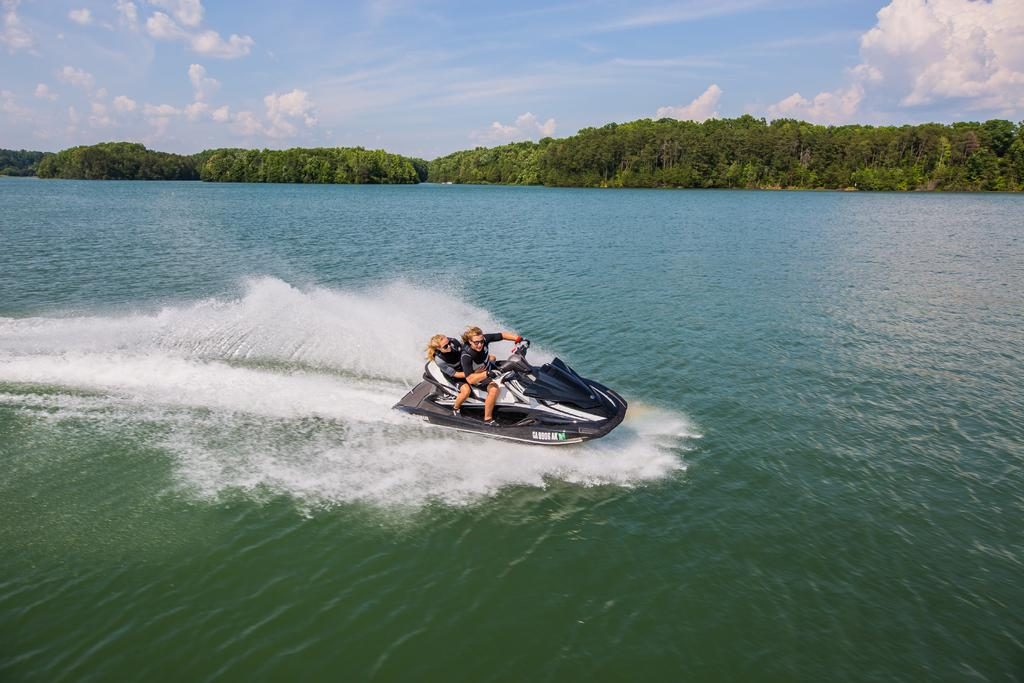How many people are in the image? There are two persons in the image. What are the two persons doing in the image? The two persons are sitting on a water bike. Where is the water bike located? The water bike is on a river. What can be seen in the background of the image? There are trees and the sky visible in the background of the image. What type of knife is being used to cut the value of the water bike in the image? There is no knife or value present in the image, and therefore no such activity can be observed. 